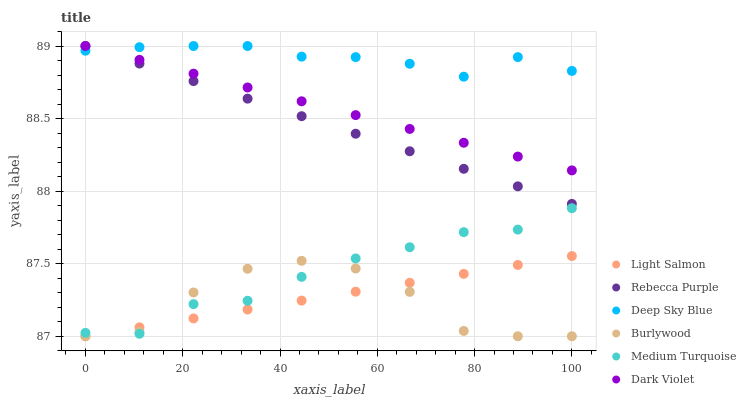Does Burlywood have the minimum area under the curve?
Answer yes or no. Yes. Does Deep Sky Blue have the maximum area under the curve?
Answer yes or no. Yes. Does Medium Turquoise have the minimum area under the curve?
Answer yes or no. No. Does Medium Turquoise have the maximum area under the curve?
Answer yes or no. No. Is Dark Violet the smoothest?
Answer yes or no. Yes. Is Burlywood the roughest?
Answer yes or no. Yes. Is Medium Turquoise the smoothest?
Answer yes or no. No. Is Medium Turquoise the roughest?
Answer yes or no. No. Does Light Salmon have the lowest value?
Answer yes or no. Yes. Does Medium Turquoise have the lowest value?
Answer yes or no. No. Does Deep Sky Blue have the highest value?
Answer yes or no. Yes. Does Medium Turquoise have the highest value?
Answer yes or no. No. Is Medium Turquoise less than Dark Violet?
Answer yes or no. Yes. Is Rebecca Purple greater than Medium Turquoise?
Answer yes or no. Yes. Does Rebecca Purple intersect Dark Violet?
Answer yes or no. Yes. Is Rebecca Purple less than Dark Violet?
Answer yes or no. No. Is Rebecca Purple greater than Dark Violet?
Answer yes or no. No. Does Medium Turquoise intersect Dark Violet?
Answer yes or no. No. 